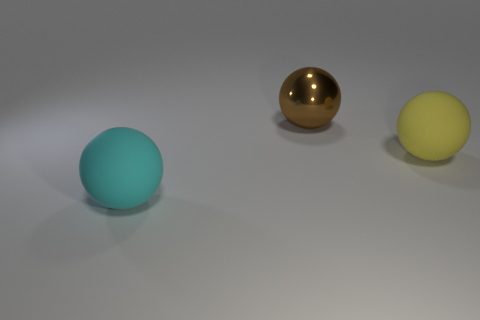Add 1 large brown shiny objects. How many objects exist? 4 Add 1 shiny balls. How many shiny balls are left? 2 Add 1 large cyan rubber things. How many large cyan rubber things exist? 2 Subtract 1 cyan spheres. How many objects are left? 2 Subtract all small green rubber cylinders. Subtract all cyan matte balls. How many objects are left? 2 